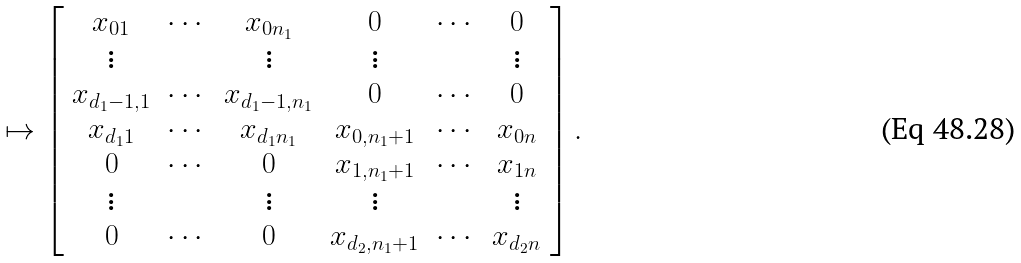Convert formula to latex. <formula><loc_0><loc_0><loc_500><loc_500>\mapsto \left [ \begin{array} { c c c c c c } x _ { 0 1 } & \cdots & x _ { 0 n _ { 1 } } & 0 & \cdots & 0 \\ \vdots & & \vdots & \vdots & & \vdots \\ x _ { d _ { 1 } - 1 , 1 } & \cdots & x _ { d _ { 1 } - 1 , n _ { 1 } } & 0 & \cdots & 0 \\ x _ { d _ { 1 } 1 } & \cdots & x _ { d _ { 1 } n _ { 1 } } & x _ { 0 , n _ { 1 } + 1 } & \cdots & x _ { 0 n } \\ 0 & \cdots & 0 & x _ { 1 , n _ { 1 } + 1 } & \cdots & x _ { 1 n } \\ \vdots & & \vdots & \vdots & & \vdots \\ 0 & \cdots & 0 & x _ { d _ { 2 } , n _ { 1 } + 1 } & \cdots & x _ { d _ { 2 } n } \\ \end{array} \right ] .</formula> 